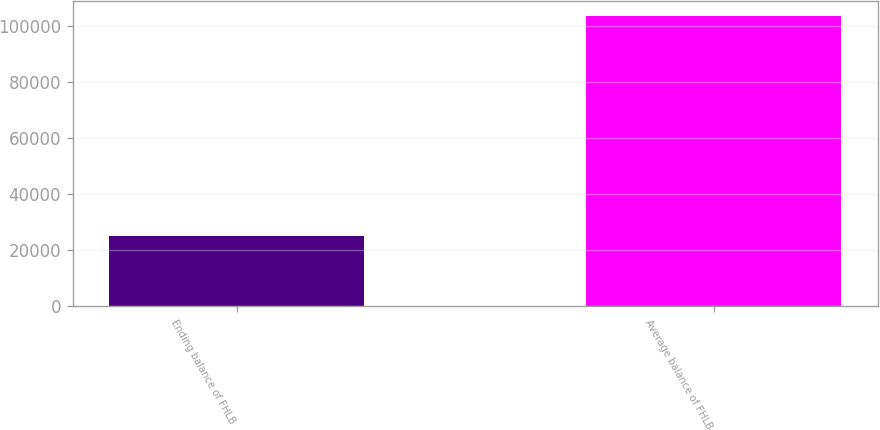Convert chart to OTSL. <chart><loc_0><loc_0><loc_500><loc_500><bar_chart><fcel>Ending balance of FHLB<fcel>Average balance of FHLB<nl><fcel>25000<fcel>103885<nl></chart> 